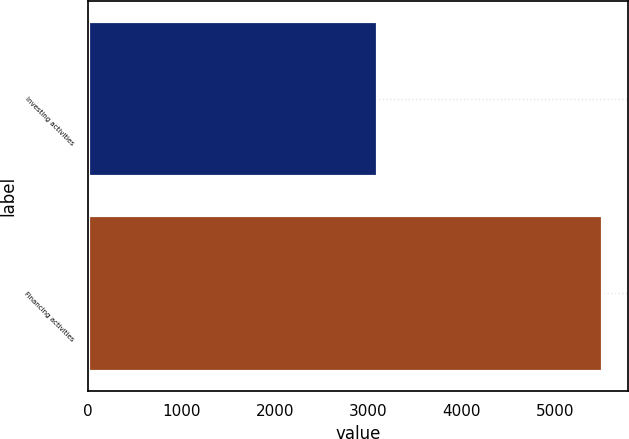<chart> <loc_0><loc_0><loc_500><loc_500><bar_chart><fcel>Investing activities<fcel>Financing activities<nl><fcel>3096<fcel>5510<nl></chart> 